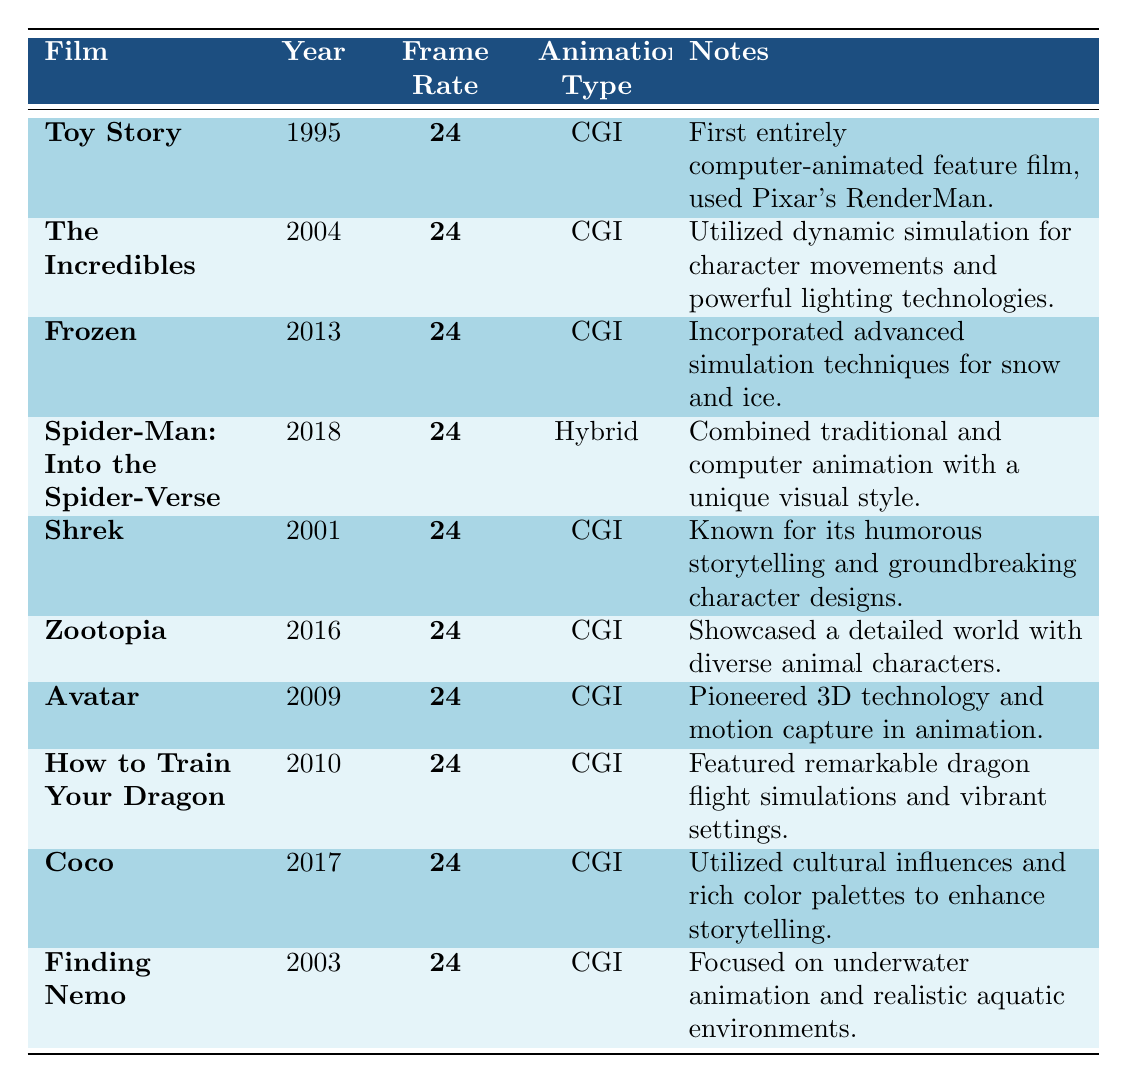What is the frame rate used in all the films listed? The table shows that all the films listed have a frame rate of **24 frames per second**. This can be confirmed by looking at the Frame Rate column for each entry.
Answer: 24 frames per second Which year was "Toy Story" released? The table clearly indicates that "Toy Story" was released in the year **1995** under the Year column.
Answer: 1995 Is "Avatar" a CGI or Hybrid animation film? According to the table, "Avatar" is classified as a **CGI** animation film, as noted in the Animation Type column.
Answer: CGI What common feature do all the films share regarding frame rate? Each film in the table has the same frame rate of **24 frames per second**. This can be deduced by comparing the values in the Frame Rate column across all entries.
Answer: 24 frames per second Which film was released in 2004 and what is its frame rate? The film "The Incredibles" was released in **2004** and has a frame rate of **24** frames per second, as detailed in the respective columns.
Answer: The Incredibles, 24 Are there any films in the table that utilize a unique visual style? Yes, "Spider-Man: Into the Spider-Verse" is noted for combining traditional and computer animation with a **unique visual style**, as indicated in the Notes column.
Answer: Yes How many CGI films were released before 2010? By counting the entries in the table, there are **seven CGI films** released before 2010, which include "Toy Story," "The Incredibles," "Shrek," "Finding Nemo," "Frozen," "Avatar," and "How to Train Your Dragon."
Answer: 7 What are the years in which the films "Coco" and "Frozen" were released? "Coco" was released in **2017** and "Frozen" in **2013**, as per the Year column for these films.
Answer: 2017 and 2013 Which film was the last to pioneer 3D technology in animation? "Avatar," released in **2009**, is the film identified in the table as having pioneered 3D technology in animation, as mentioned in the Notes.
Answer: Avatar What is the average frame rate of animation films listed in the table? All films have a frame rate of **24**, so the sum total is 24 * 10 = 240 and the average is 240 / 10 = 24. Hence, the average frame rate is **24 frames per second**.
Answer: 24 frames per second 